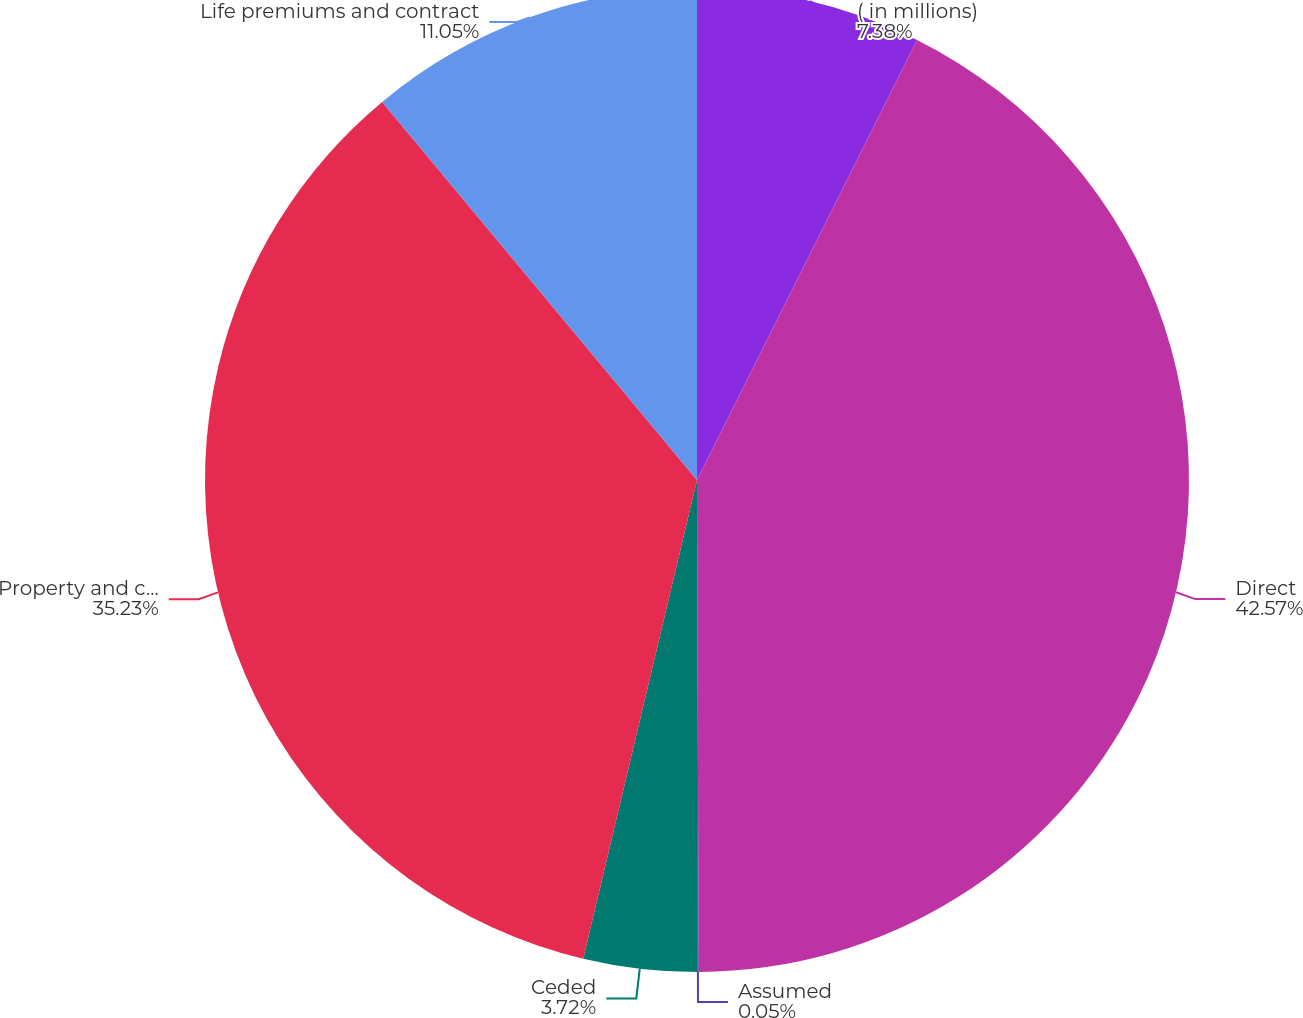Convert chart. <chart><loc_0><loc_0><loc_500><loc_500><pie_chart><fcel>( in millions)<fcel>Direct<fcel>Assumed<fcel>Ceded<fcel>Property and casualty<fcel>Life premiums and contract<nl><fcel>7.38%<fcel>42.56%<fcel>0.05%<fcel>3.72%<fcel>35.23%<fcel>11.05%<nl></chart> 